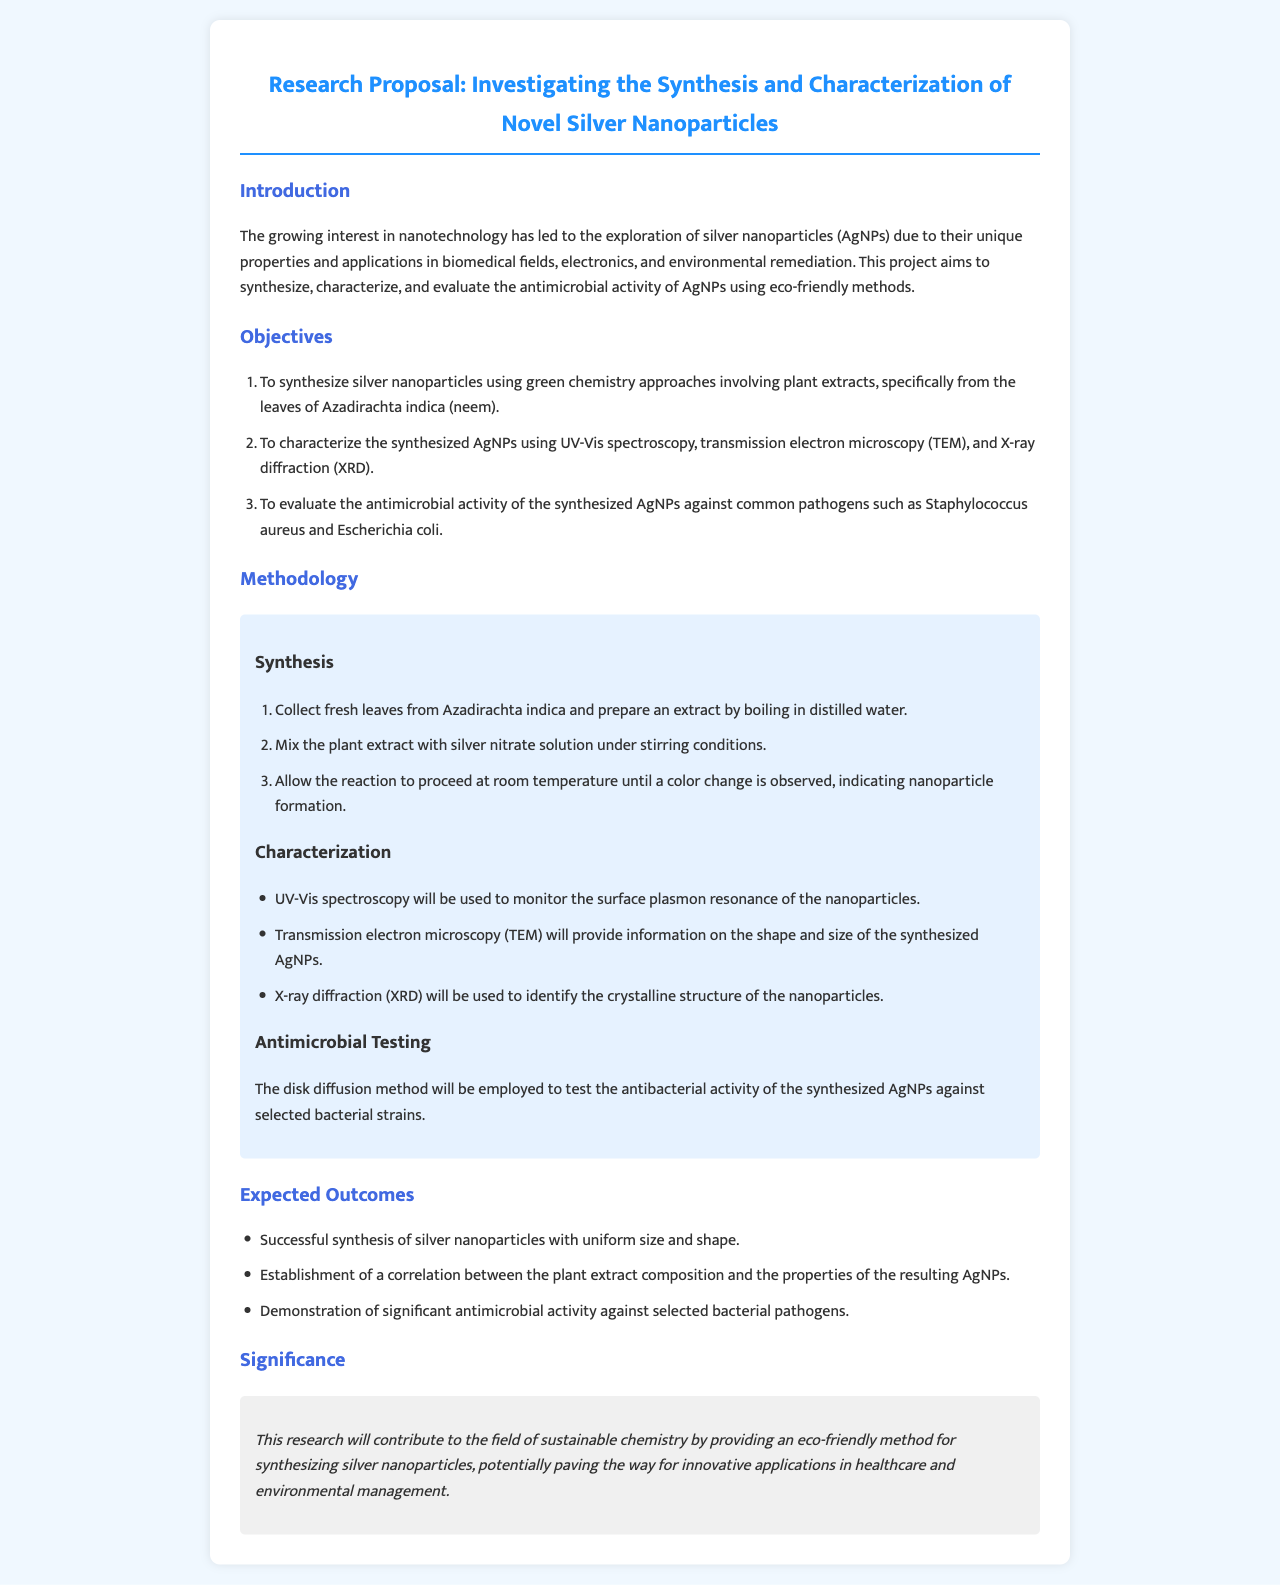What is the title of the research proposal? The title of the research proposal is mentioned at the beginning of the document.
Answer: Investigating the Synthesis and Characterization of Novel Silver Nanoparticles What is the first objective of the research? The first objective can be found in the list of objectives in the document.
Answer: To synthesize silver nanoparticles using green chemistry approaches involving plant extracts, specifically from the leaves of Azadirachta indica (neem) Which method is used for antimicrobial testing? The specific method is stated under the methodology section related to antimicrobial testing.
Answer: Disk diffusion method What analytical technique is used to determine the shape and size of the nanoparticles? This information can be retrieved from the characterization section of the methodology.
Answer: Transmission electron microscopy (TEM) What is one expected outcome of the research? Expected outcomes are listed in the document, and one can be retrieved directly.
Answer: Successful synthesis of silver nanoparticles with uniform size and shape How many objectives are stated in the document? This information is about counting the items listed in the objectives section.
Answer: Three What is the main significance of this research? The significance is summarized in the significance section at the end of the proposal.
Answer: Contribute to the field of sustainable chemistry Which plant extract is used for synthesizing silver nanoparticles? The answer is provided under the synthesis section in the methodology.
Answer: Azadirachta indica (neem) What will the X-ray diffraction (XRD) be used for? This detail is mentioned under the characterization methods in the document.
Answer: To identify the crystalline structure of the nanoparticles 